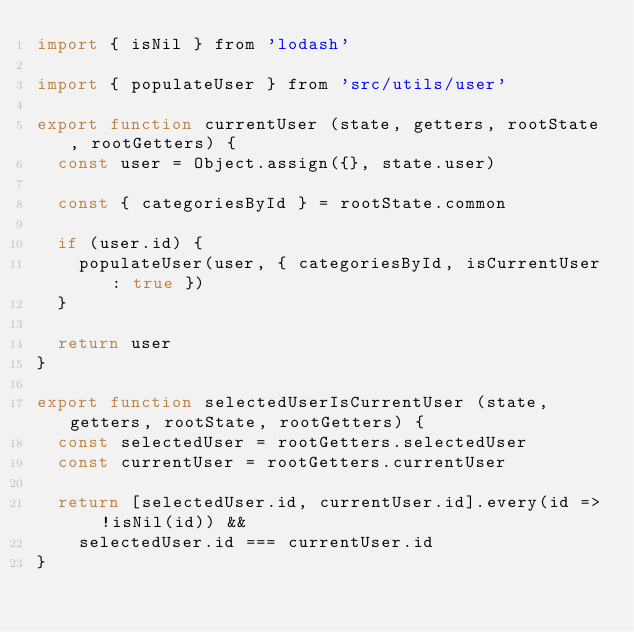Convert code to text. <code><loc_0><loc_0><loc_500><loc_500><_JavaScript_>import { isNil } from 'lodash'

import { populateUser } from 'src/utils/user'

export function currentUser (state, getters, rootState, rootGetters) {
  const user = Object.assign({}, state.user)

  const { categoriesById } = rootState.common

  if (user.id) {
    populateUser(user, { categoriesById, isCurrentUser: true })
  }

  return user
}

export function selectedUserIsCurrentUser (state, getters, rootState, rootGetters) {
  const selectedUser = rootGetters.selectedUser
  const currentUser = rootGetters.currentUser

  return [selectedUser.id, currentUser.id].every(id => !isNil(id)) &&
    selectedUser.id === currentUser.id
}
</code> 